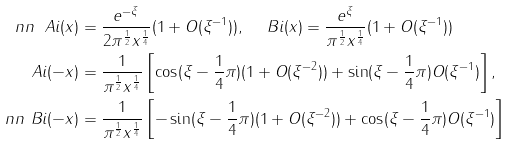Convert formula to latex. <formula><loc_0><loc_0><loc_500><loc_500>\ n n \ A i ( x ) & = \frac { e ^ { - \xi } } { 2 \pi ^ { \frac { 1 } { 2 } } x ^ { \frac { 1 } { 4 } } } ( 1 + O ( \xi ^ { - 1 } ) ) , \quad \ B i ( x ) = \frac { e ^ { \xi } } { \pi ^ { \frac { 1 } { 2 } } x ^ { \frac { 1 } { 4 } } } ( 1 + O ( \xi ^ { - 1 } ) ) \\ \ A i ( - x ) & = \frac { 1 } { \pi ^ { \frac { 1 } { 2 } } x ^ { \frac { 1 } { 4 } } } \left [ \cos ( \xi - \frac { 1 } { 4 } \pi ) ( 1 + O ( \xi ^ { - 2 } ) ) + \sin ( \xi - \frac { 1 } { 4 } \pi ) O ( \xi ^ { - 1 } ) \right ] , \\ \ n n \ B i ( - x ) & = \frac { 1 } { \pi ^ { \frac { 1 } { 2 } } x ^ { \frac { 1 } { 4 } } } \left [ - \sin ( \xi - \frac { 1 } { 4 } \pi ) ( 1 + O ( \xi ^ { - 2 } ) ) + \cos ( \xi - \frac { 1 } { 4 } \pi ) O ( \xi ^ { - 1 } ) \right ]</formula> 